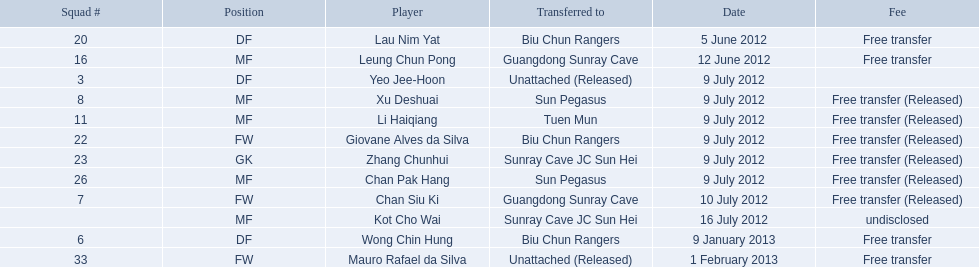Which players are listed? Lau Nim Yat, Leung Chun Pong, Yeo Jee-Hoon, Xu Deshuai, Li Haiqiang, Giovane Alves da Silva, Zhang Chunhui, Chan Pak Hang, Chan Siu Ki, Kot Cho Wai, Wong Chin Hung, Mauro Rafael da Silva. Which dates were players transferred to the biu chun rangers? 5 June 2012, 9 July 2012, 9 January 2013. Of those which is the date for wong chin hung? 9 January 2013. 